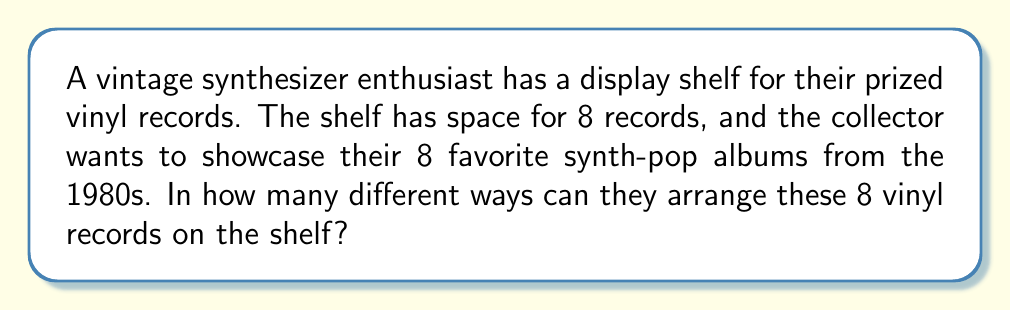Can you answer this question? To solve this problem, we need to understand that this is a permutation question. We are arranging all 8 records, and the order matters (as it's a display).

The formula for permutations when all items are used is:

$$P(n) = n!$$

Where $n$ is the number of items to be arranged.

In this case, $n = 8$ (the number of vinyl records).

So, we calculate:

$$P(8) = 8!$$

$$8! = 8 \times 7 \times 6 \times 5 \times 4 \times 3 \times 2 \times 1$$

$$8! = 40,320$$

This means there are 40,320 different ways to arrange the 8 vinyl records on the display shelf.

To break it down:
1. For the first position, there are 8 choices.
2. For the second position, there are 7 remaining choices.
3. For the third position, there are 6 remaining choices.
4. And so on, until all records are placed.

This multiplication of decreasing integers is what factorial represents, hence why we use $8!$ for this calculation.
Answer: 40,320 different arrangements 